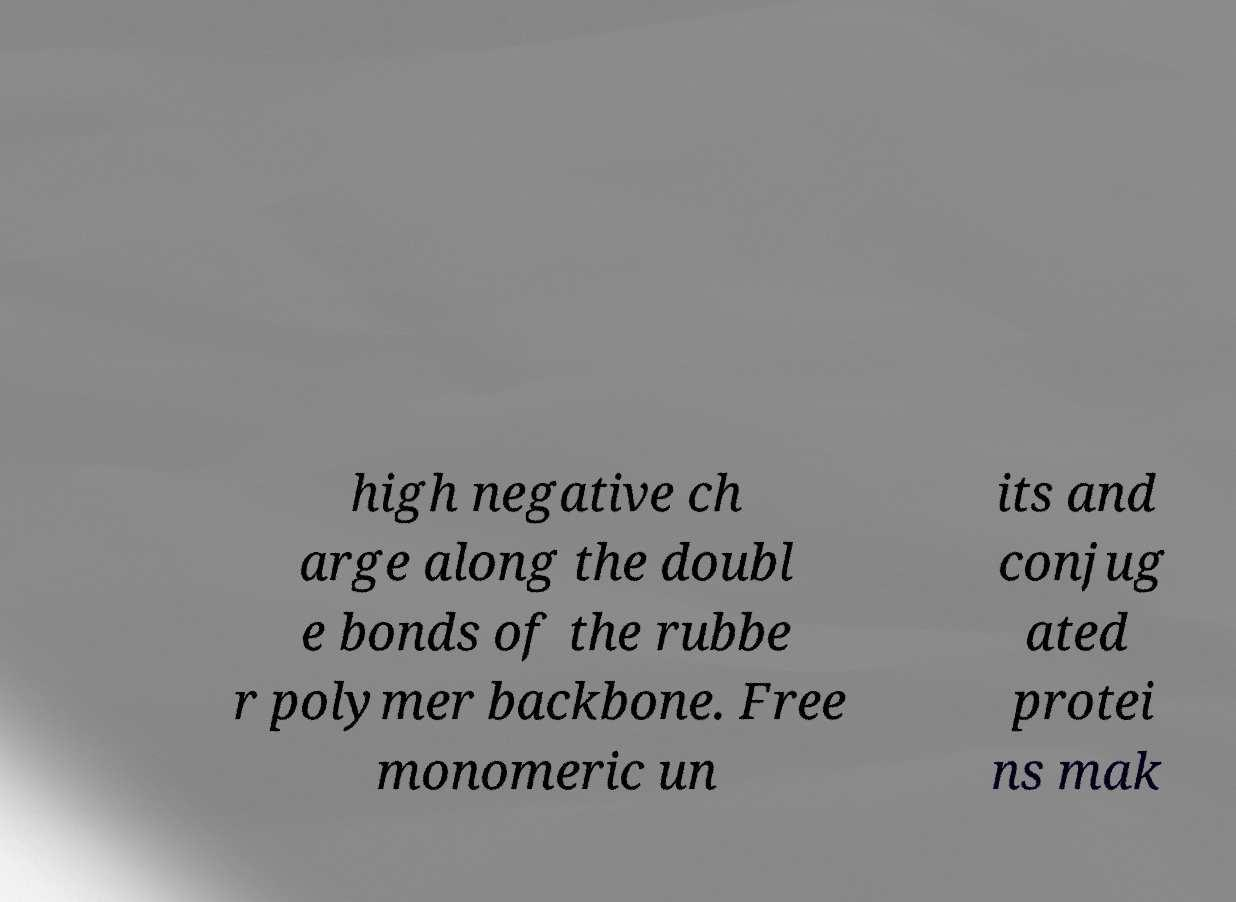Please identify and transcribe the text found in this image. high negative ch arge along the doubl e bonds of the rubbe r polymer backbone. Free monomeric un its and conjug ated protei ns mak 